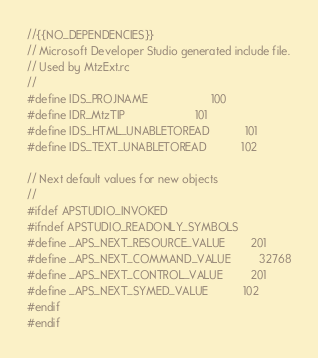Convert code to text. <code><loc_0><loc_0><loc_500><loc_500><_C_>//{{NO_DEPENDENCIES}}
// Microsoft Developer Studio generated include file.
// Used by MtzExt.rc
//
#define IDS_PROJNAME                    100
#define IDR_MtzTIP                      101
#define IDS_HTML_UNABLETOREAD           101
#define IDS_TEXT_UNABLETOREAD           102

// Next default values for new objects
// 
#ifdef APSTUDIO_INVOKED
#ifndef APSTUDIO_READONLY_SYMBOLS
#define _APS_NEXT_RESOURCE_VALUE        201
#define _APS_NEXT_COMMAND_VALUE         32768
#define _APS_NEXT_CONTROL_VALUE         201
#define _APS_NEXT_SYMED_VALUE           102
#endif
#endif
</code> 